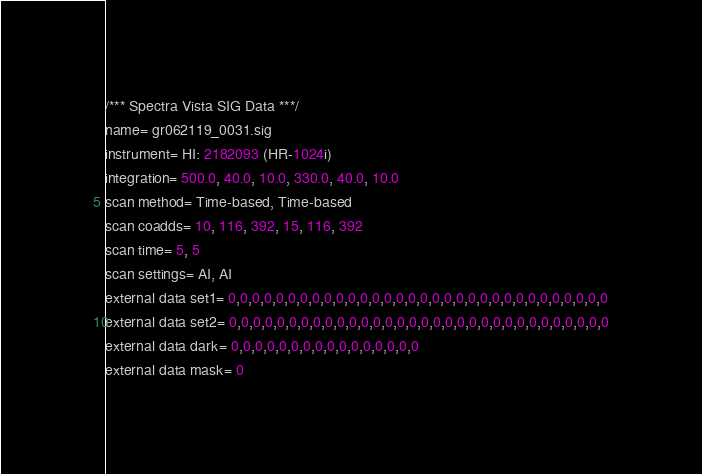<code> <loc_0><loc_0><loc_500><loc_500><_SML_>/*** Spectra Vista SIG Data ***/
name= gr062119_0031.sig
instrument= HI: 2182093 (HR-1024i)
integration= 500.0, 40.0, 10.0, 330.0, 40.0, 10.0
scan method= Time-based, Time-based
scan coadds= 10, 116, 392, 15, 116, 392
scan time= 5, 5
scan settings= AI, AI
external data set1= 0,0,0,0,0,0,0,0,0,0,0,0,0,0,0,0,0,0,0,0,0,0,0,0,0,0,0,0,0,0,0,0
external data set2= 0,0,0,0,0,0,0,0,0,0,0,0,0,0,0,0,0,0,0,0,0,0,0,0,0,0,0,0,0,0,0,0
external data dark= 0,0,0,0,0,0,0,0,0,0,0,0,0,0,0,0
external data mask= 0</code> 